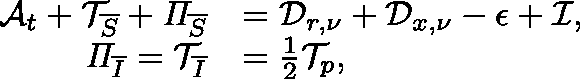Convert formula to latex. <formula><loc_0><loc_0><loc_500><loc_500>\begin{array} { r l } { \mathcal { A } _ { t } + \mathcal { T } _ { \overline { S } } + \Pi _ { \overline { S } } } & { = \mathcal { D } _ { r , \nu } + \mathcal { D } _ { x , \nu } - \mathcal { \epsilon } + \mathcal { I } , } \\ { \Pi _ { \overline { I } } = \mathcal { T } _ { \overline { I } } } & { = \frac { 1 } { 2 } \mathcal { T } _ { p } , } \end{array}</formula> 